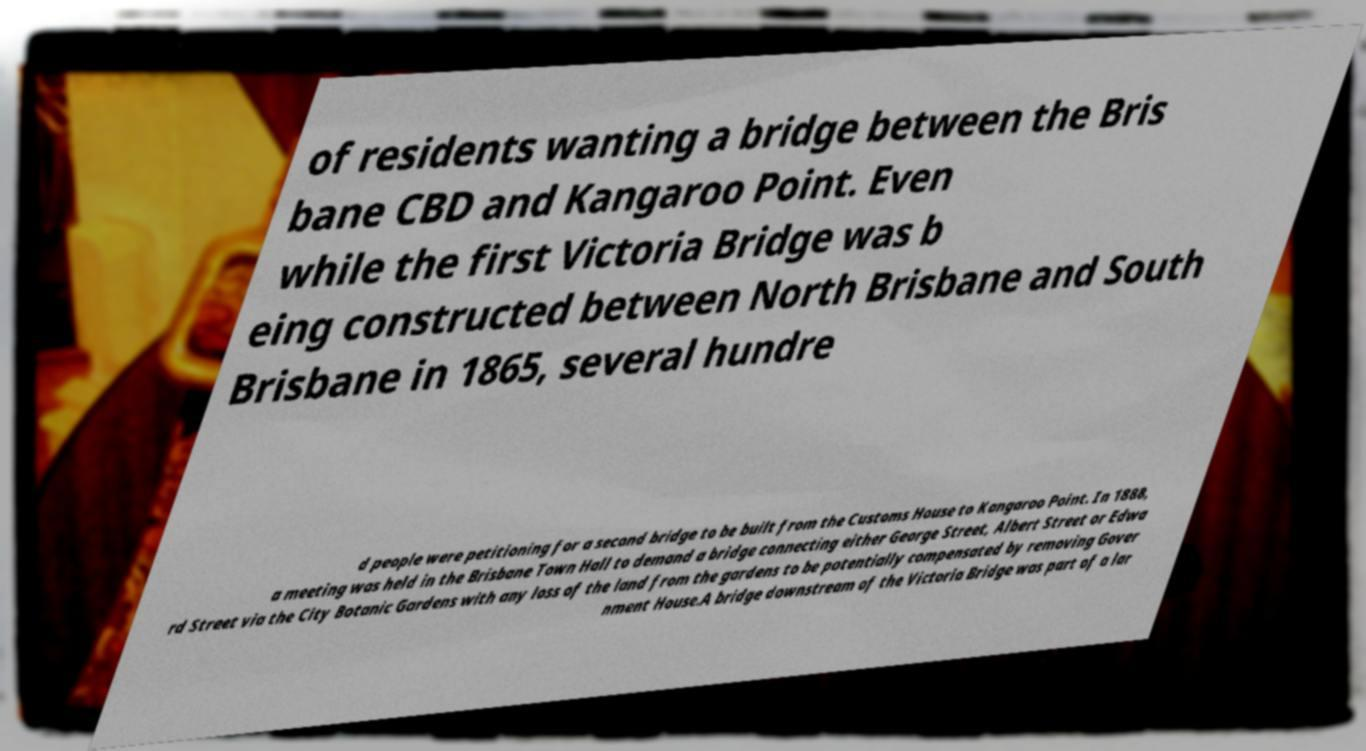Please read and relay the text visible in this image. What does it say? of residents wanting a bridge between the Bris bane CBD and Kangaroo Point. Even while the first Victoria Bridge was b eing constructed between North Brisbane and South Brisbane in 1865, several hundre d people were petitioning for a second bridge to be built from the Customs House to Kangaroo Point. In 1888, a meeting was held in the Brisbane Town Hall to demand a bridge connecting either George Street, Albert Street or Edwa rd Street via the City Botanic Gardens with any loss of the land from the gardens to be potentially compensated by removing Gover nment House.A bridge downstream of the Victoria Bridge was part of a lar 